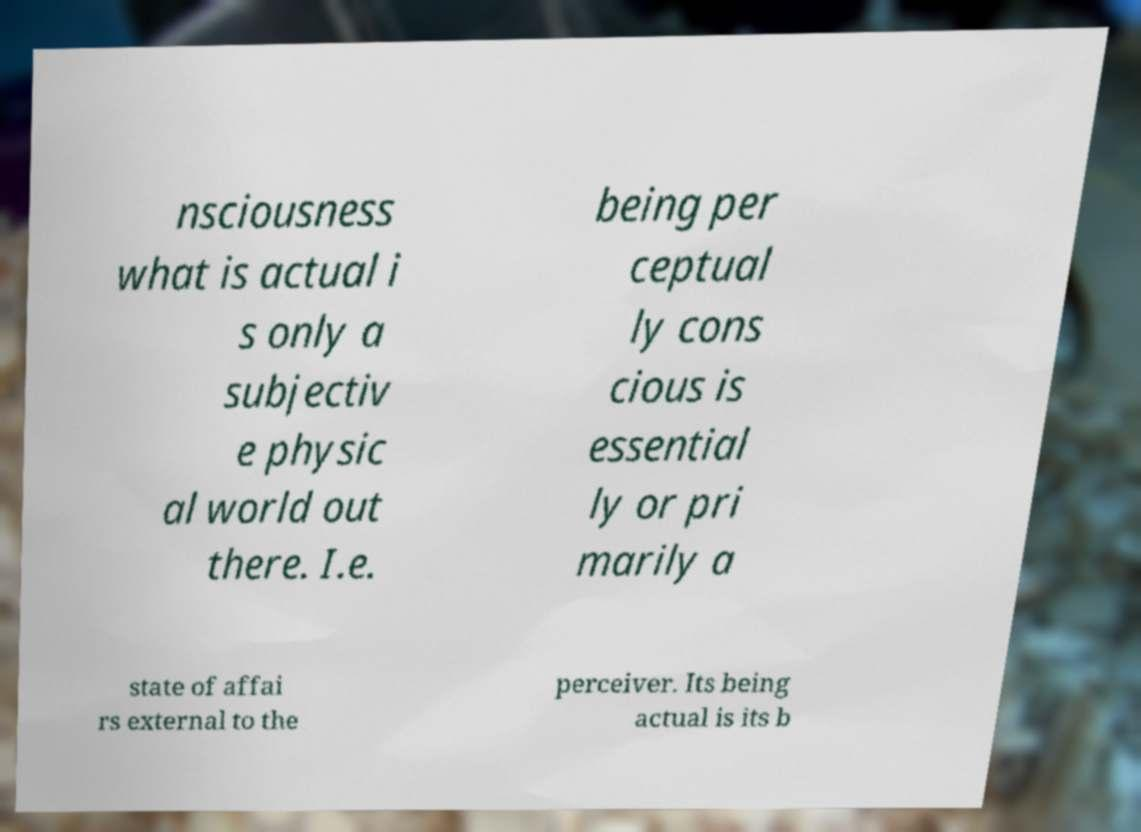For documentation purposes, I need the text within this image transcribed. Could you provide that? nsciousness what is actual i s only a subjectiv e physic al world out there. I.e. being per ceptual ly cons cious is essential ly or pri marily a state of affai rs external to the perceiver. Its being actual is its b 